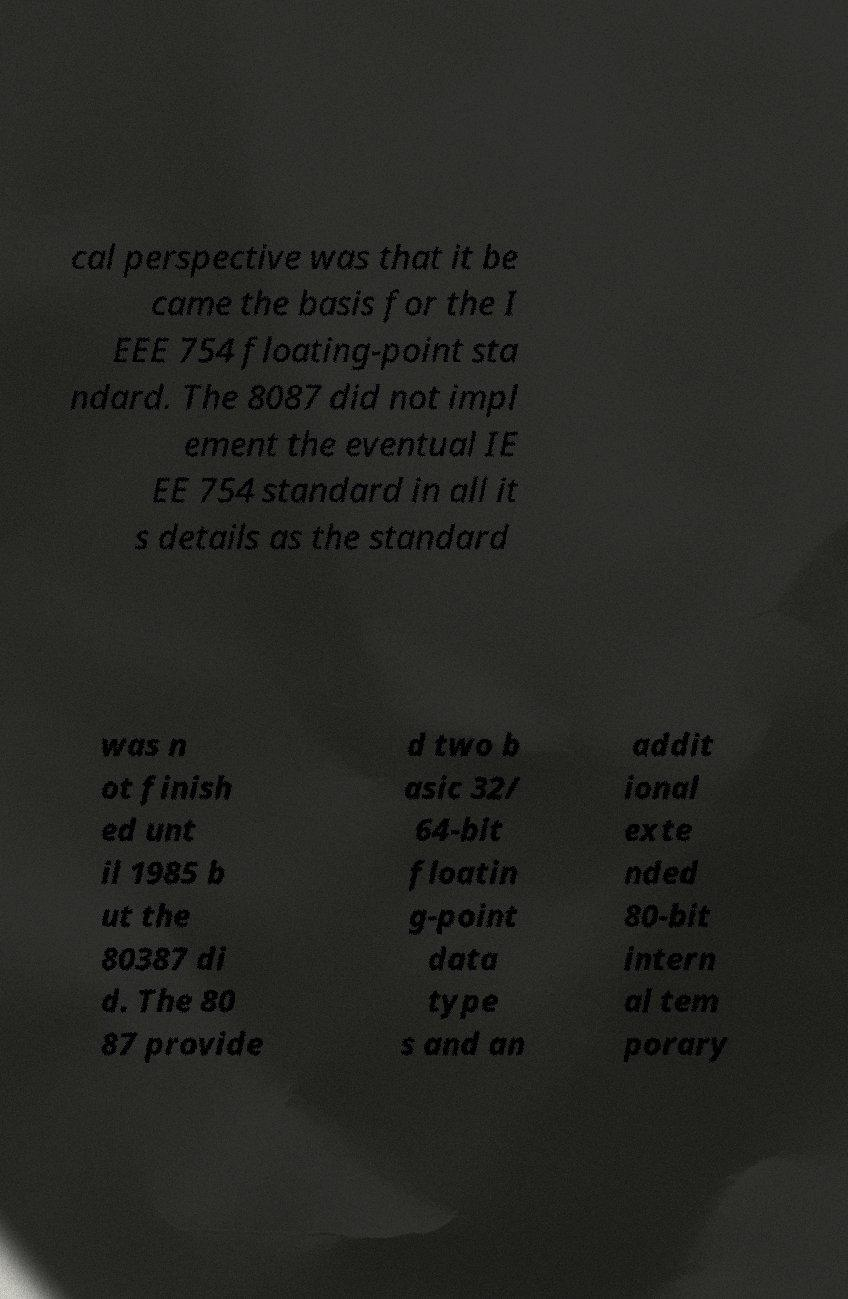Please identify and transcribe the text found in this image. cal perspective was that it be came the basis for the I EEE 754 floating-point sta ndard. The 8087 did not impl ement the eventual IE EE 754 standard in all it s details as the standard was n ot finish ed unt il 1985 b ut the 80387 di d. The 80 87 provide d two b asic 32/ 64-bit floatin g-point data type s and an addit ional exte nded 80-bit intern al tem porary 